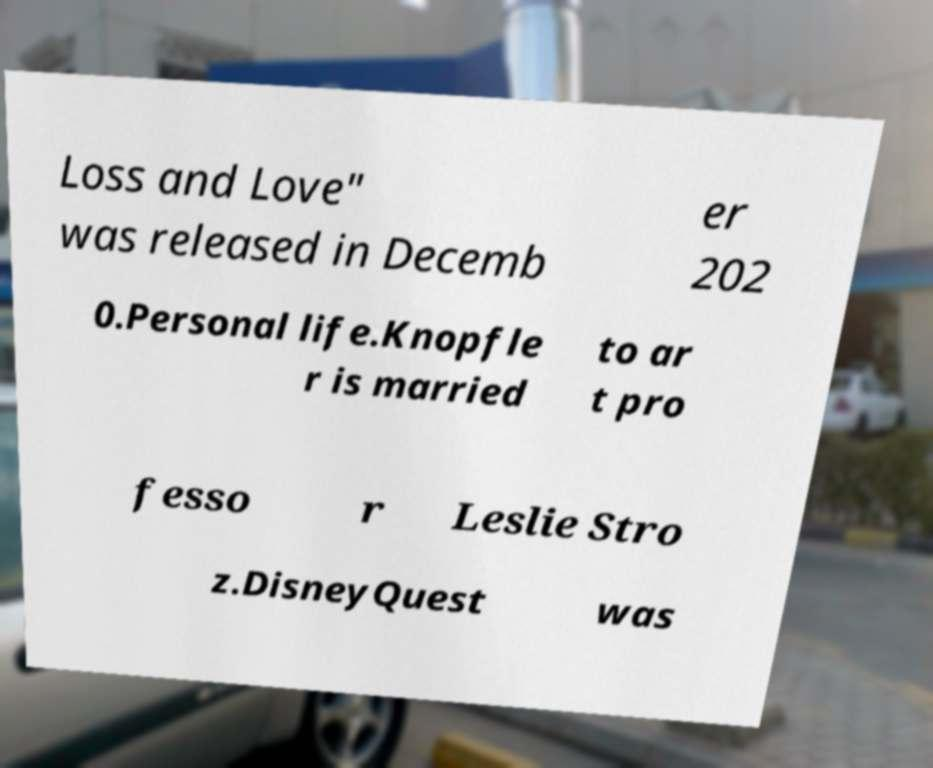Please read and relay the text visible in this image. What does it say? Loss and Love" was released in Decemb er 202 0.Personal life.Knopfle r is married to ar t pro fesso r Leslie Stro z.DisneyQuest was 